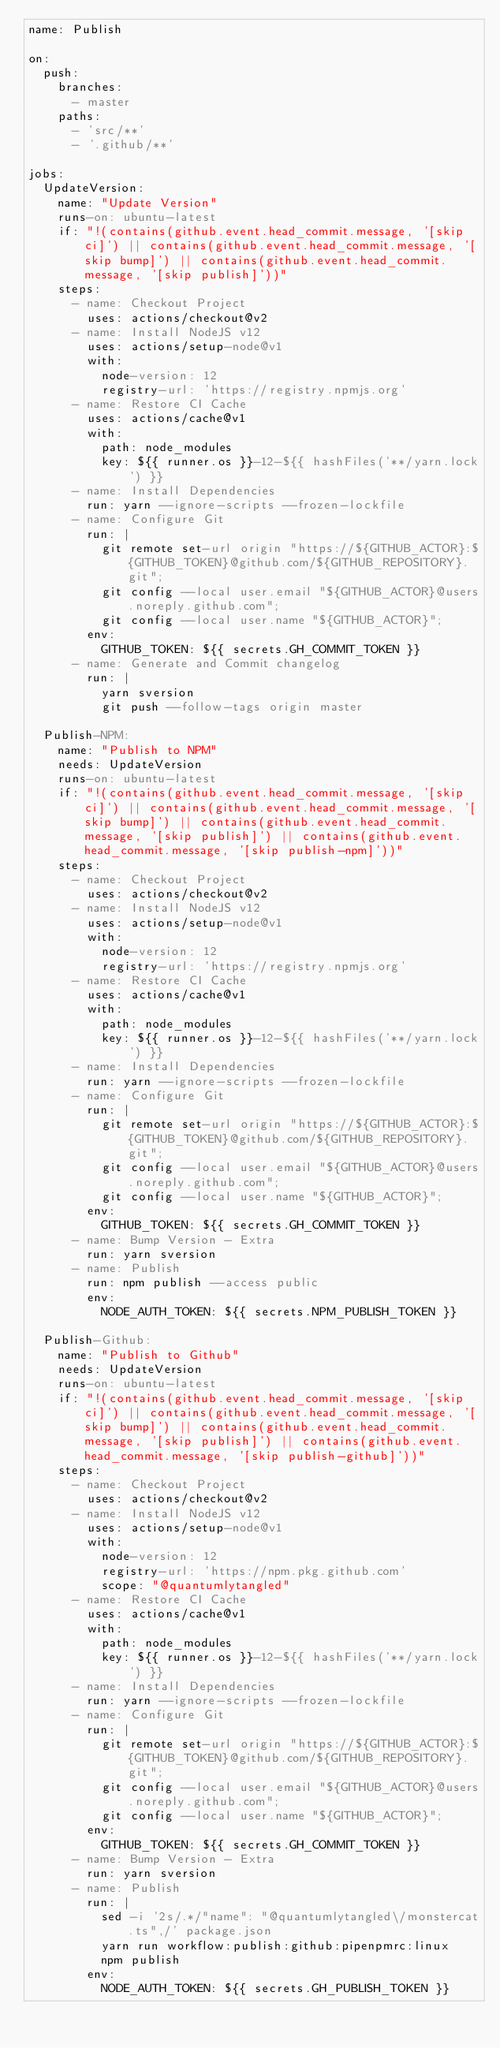<code> <loc_0><loc_0><loc_500><loc_500><_YAML_>name: Publish

on:
  push:
    branches:
      - master
    paths:
      - 'src/**'
      - '.github/**'

jobs:
  UpdateVersion:
    name: "Update Version"
    runs-on: ubuntu-latest
    if: "!(contains(github.event.head_commit.message, '[skip ci]') || contains(github.event.head_commit.message, '[skip bump]') || contains(github.event.head_commit.message, '[skip publish]'))"
    steps:
      - name: Checkout Project
        uses: actions/checkout@v2
      - name: Install NodeJS v12
        uses: actions/setup-node@v1
        with:
          node-version: 12
          registry-url: 'https://registry.npmjs.org'
      - name: Restore CI Cache
        uses: actions/cache@v1
        with:
          path: node_modules
          key: ${{ runner.os }}-12-${{ hashFiles('**/yarn.lock') }}
      - name: Install Dependencies
        run: yarn --ignore-scripts --frozen-lockfile
      - name: Configure Git
        run: |
          git remote set-url origin "https://${GITHUB_ACTOR}:${GITHUB_TOKEN}@github.com/${GITHUB_REPOSITORY}.git";
          git config --local user.email "${GITHUB_ACTOR}@users.noreply.github.com";
          git config --local user.name "${GITHUB_ACTOR}";
        env:
          GITHUB_TOKEN: ${{ secrets.GH_COMMIT_TOKEN }}
      - name: Generate and Commit changelog
        run: |
          yarn sversion
          git push --follow-tags origin master

  Publish-NPM:
    name: "Publish to NPM"
    needs: UpdateVersion
    runs-on: ubuntu-latest
    if: "!(contains(github.event.head_commit.message, '[skip ci]') || contains(github.event.head_commit.message, '[skip bump]') || contains(github.event.head_commit.message, '[skip publish]') || contains(github.event.head_commit.message, '[skip publish-npm]'))"
    steps:
      - name: Checkout Project
        uses: actions/checkout@v2
      - name: Install NodeJS v12
        uses: actions/setup-node@v1
        with:
          node-version: 12
          registry-url: 'https://registry.npmjs.org'
      - name: Restore CI Cache
        uses: actions/cache@v1
        with:
          path: node_modules
          key: ${{ runner.os }}-12-${{ hashFiles('**/yarn.lock') }}
      - name: Install Dependencies
        run: yarn --ignore-scripts --frozen-lockfile
      - name: Configure Git
        run: |
          git remote set-url origin "https://${GITHUB_ACTOR}:${GITHUB_TOKEN}@github.com/${GITHUB_REPOSITORY}.git";
          git config --local user.email "${GITHUB_ACTOR}@users.noreply.github.com";
          git config --local user.name "${GITHUB_ACTOR}";
        env:
          GITHUB_TOKEN: ${{ secrets.GH_COMMIT_TOKEN }}
      - name: Bump Version - Extra
        run: yarn sversion
      - name: Publish
        run: npm publish --access public
        env:
          NODE_AUTH_TOKEN: ${{ secrets.NPM_PUBLISH_TOKEN }}

  Publish-Github:
    name: "Publish to Github"
    needs: UpdateVersion
    runs-on: ubuntu-latest
    if: "!(contains(github.event.head_commit.message, '[skip ci]') || contains(github.event.head_commit.message, '[skip bump]') || contains(github.event.head_commit.message, '[skip publish]') || contains(github.event.head_commit.message, '[skip publish-github]'))"
    steps:
      - name: Checkout Project
        uses: actions/checkout@v2
      - name: Install NodeJS v12
        uses: actions/setup-node@v1
        with:
          node-version: 12
          registry-url: 'https://npm.pkg.github.com'
          scope: "@quantumlytangled"
      - name: Restore CI Cache
        uses: actions/cache@v1
        with:
          path: node_modules
          key: ${{ runner.os }}-12-${{ hashFiles('**/yarn.lock') }}
      - name: Install Dependencies
        run: yarn --ignore-scripts --frozen-lockfile
      - name: Configure Git
        run: |
          git remote set-url origin "https://${GITHUB_ACTOR}:${GITHUB_TOKEN}@github.com/${GITHUB_REPOSITORY}.git";
          git config --local user.email "${GITHUB_ACTOR}@users.noreply.github.com";
          git config --local user.name "${GITHUB_ACTOR}";
        env:
          GITHUB_TOKEN: ${{ secrets.GH_COMMIT_TOKEN }}
      - name: Bump Version - Extra
        run: yarn sversion
      - name: Publish
        run: |
          sed -i '2s/.*/"name": "@quantumlytangled\/monstercat.ts",/' package.json
          yarn run workflow:publish:github:pipenpmrc:linux
          npm publish
        env:
          NODE_AUTH_TOKEN: ${{ secrets.GH_PUBLISH_TOKEN }}
</code> 